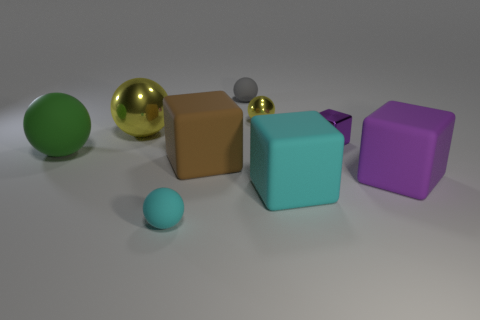Subtract all cyan matte balls. How many balls are left? 4 Subtract all green balls. How many balls are left? 4 Subtract all brown balls. Subtract all gray cubes. How many balls are left? 5 Add 1 large blue rubber things. How many objects exist? 10 Subtract all balls. How many objects are left? 4 Subtract 1 green spheres. How many objects are left? 8 Subtract all large metallic cylinders. Subtract all purple rubber blocks. How many objects are left? 8 Add 3 large yellow metallic things. How many large yellow metallic things are left? 4 Add 7 large red matte balls. How many large red matte balls exist? 7 